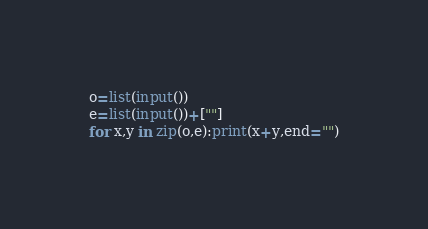Convert code to text. <code><loc_0><loc_0><loc_500><loc_500><_Python_>o=list(input())
e=list(input())+[""]
for x,y in zip(o,e):print(x+y,end="")</code> 